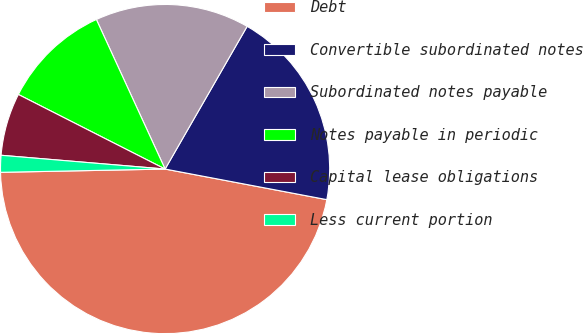<chart> <loc_0><loc_0><loc_500><loc_500><pie_chart><fcel>Debt<fcel>Convertible subordinated notes<fcel>Subordinated notes payable<fcel>Notes payable in periodic<fcel>Capital lease obligations<fcel>Less current portion<nl><fcel>46.71%<fcel>19.67%<fcel>15.16%<fcel>10.66%<fcel>6.15%<fcel>1.65%<nl></chart> 